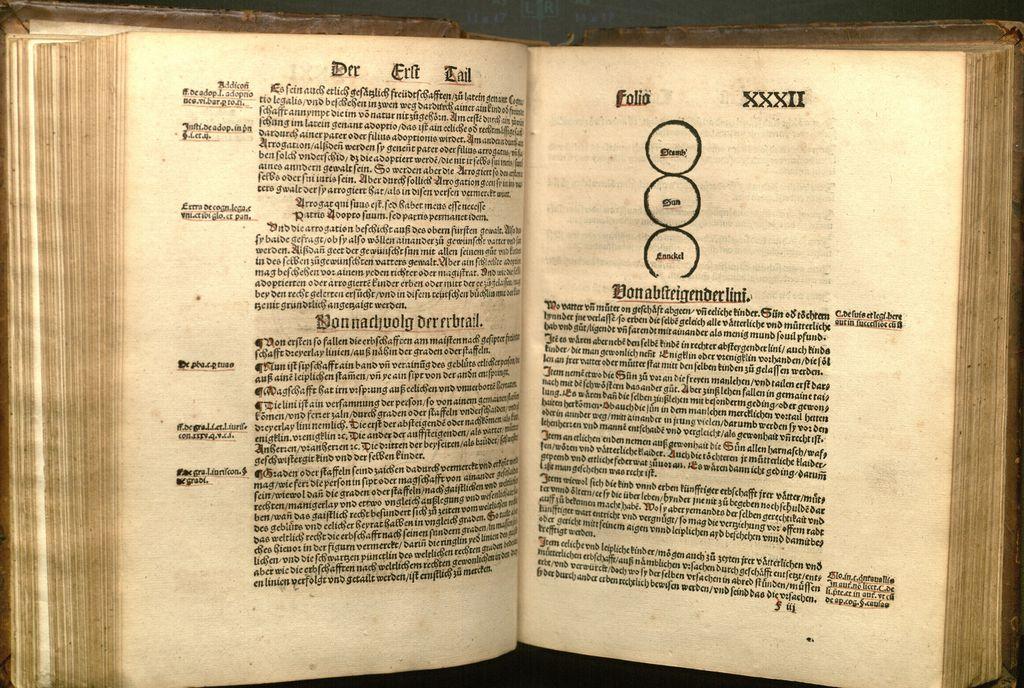What are the roman numerals shown?
Your answer should be compact. Xxxii. 